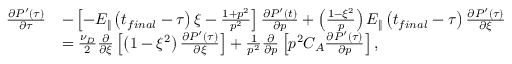<formula> <loc_0><loc_0><loc_500><loc_500>\begin{array} { r l } { \frac { \partial P ^ { \prime } \left ( \tau \right ) } { \partial \tau } } & { - \left [ - E _ { \| } \left ( t _ { f i n a l } - \tau \right ) \xi - \frac { 1 + p ^ { 2 } } { p ^ { 2 } } \right ] \frac { \partial P ^ { \prime } \left ( t \right ) } { \partial p } + \left ( \frac { 1 - \xi ^ { 2 } } { p } \right ) E _ { \| } \left ( t _ { f i n a l } - \tau \right ) \frac { \partial P ^ { \prime } \left ( \tau \right ) } { \partial \xi } } \\ & { = \frac { \nu _ { D } } { 2 } \frac { \partial } { \partial \xi } \left [ \left ( 1 - \xi ^ { 2 } \right ) \frac { \partial P ^ { \prime } \left ( \tau \right ) } { \partial \xi } \right ] + \frac { 1 } { p ^ { 2 } } \frac { \partial } { \partial p } \left [ p ^ { 2 } C _ { A } \frac { \partial P ^ { \prime } \left ( \tau \right ) } { \partial p } \right ] , } \end{array}</formula> 